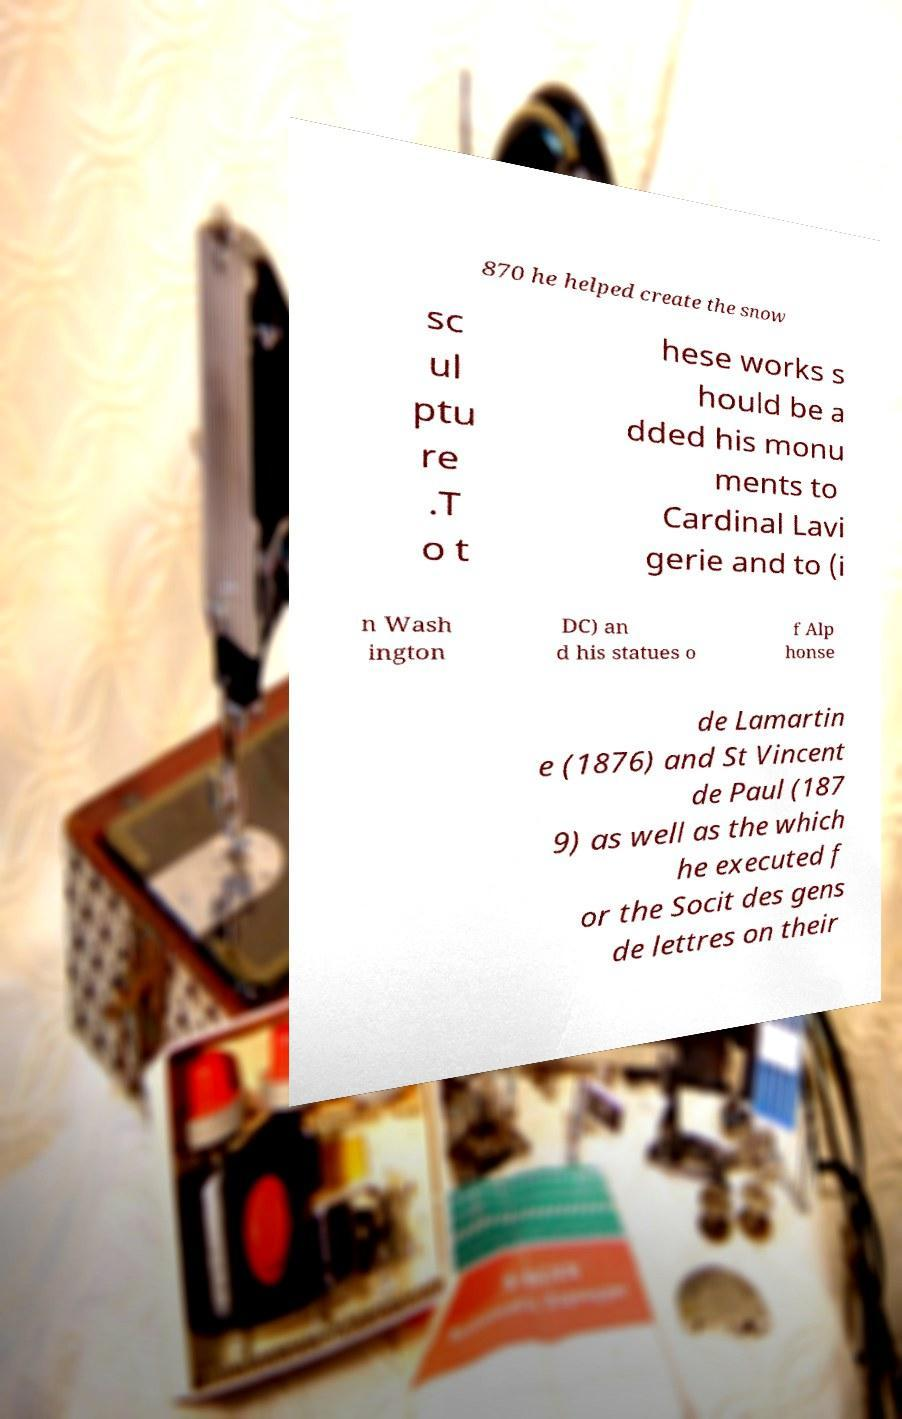I need the written content from this picture converted into text. Can you do that? 870 he helped create the snow sc ul ptu re .T o t hese works s hould be a dded his monu ments to Cardinal Lavi gerie and to (i n Wash ington DC) an d his statues o f Alp honse de Lamartin e (1876) and St Vincent de Paul (187 9) as well as the which he executed f or the Socit des gens de lettres on their 